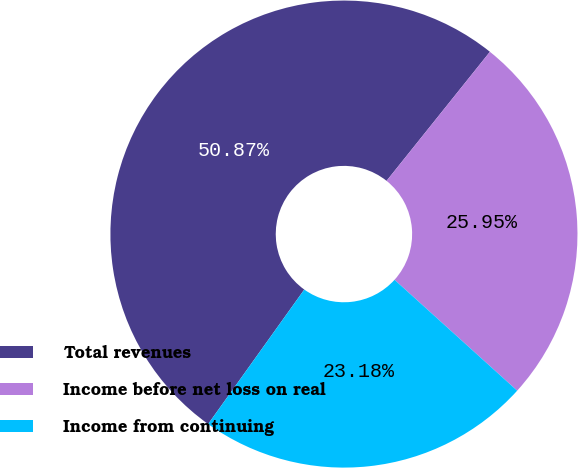Convert chart. <chart><loc_0><loc_0><loc_500><loc_500><pie_chart><fcel>Total revenues<fcel>Income before net loss on real<fcel>Income from continuing<nl><fcel>50.87%<fcel>25.95%<fcel>23.18%<nl></chart> 